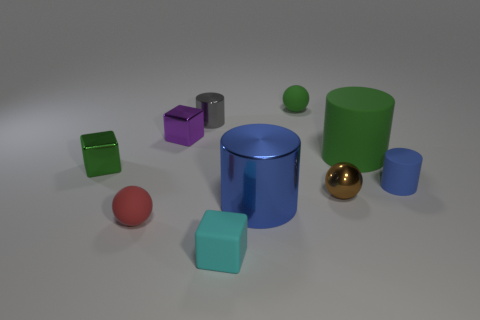There is a tiny matte object that is the same color as the large matte cylinder; what shape is it?
Your response must be concise. Sphere. Do the small ball that is on the left side of the cyan cube and the rubber cylinder left of the blue rubber cylinder have the same color?
Provide a short and direct response. No. How many small rubber spheres are both behind the big green cylinder and in front of the tiny blue cylinder?
Your answer should be compact. 0. What is the tiny blue cylinder made of?
Keep it short and to the point. Rubber. There is a red rubber thing that is the same size as the green block; what shape is it?
Your answer should be compact. Sphere. Is the small ball that is to the left of the cyan block made of the same material as the cylinder that is on the left side of the tiny cyan block?
Offer a terse response. No. What number of small green balls are there?
Provide a succinct answer. 1. How many large green rubber objects have the same shape as the purple object?
Offer a very short reply. 0. Does the tiny blue matte thing have the same shape as the purple object?
Provide a succinct answer. No. The rubber cube has what size?
Your answer should be very brief. Small. 